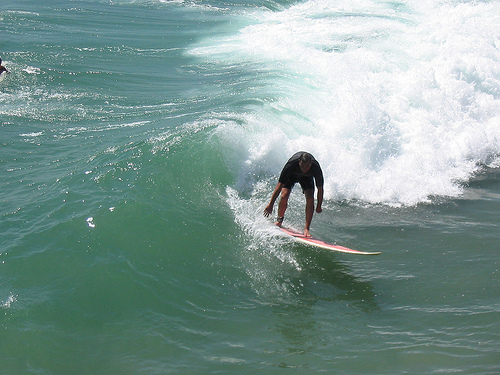Describe the overall mood of the scene captured in the image. The overall mood of the scene is energetic and thrilling, capturing a moment of intense concentration and skill as the surfer navigates the powerful wave. The combination of the dynamic water and the focused posture of the surfer emphasizes the excitement and challenge of surfing. What can you say about the likely skill level of the surfer? The surfer appears to have a high skill level. His balanced stance, forward-leaning posture, and the control shown while riding such a large wave indicate experience and confidence in surfing. 